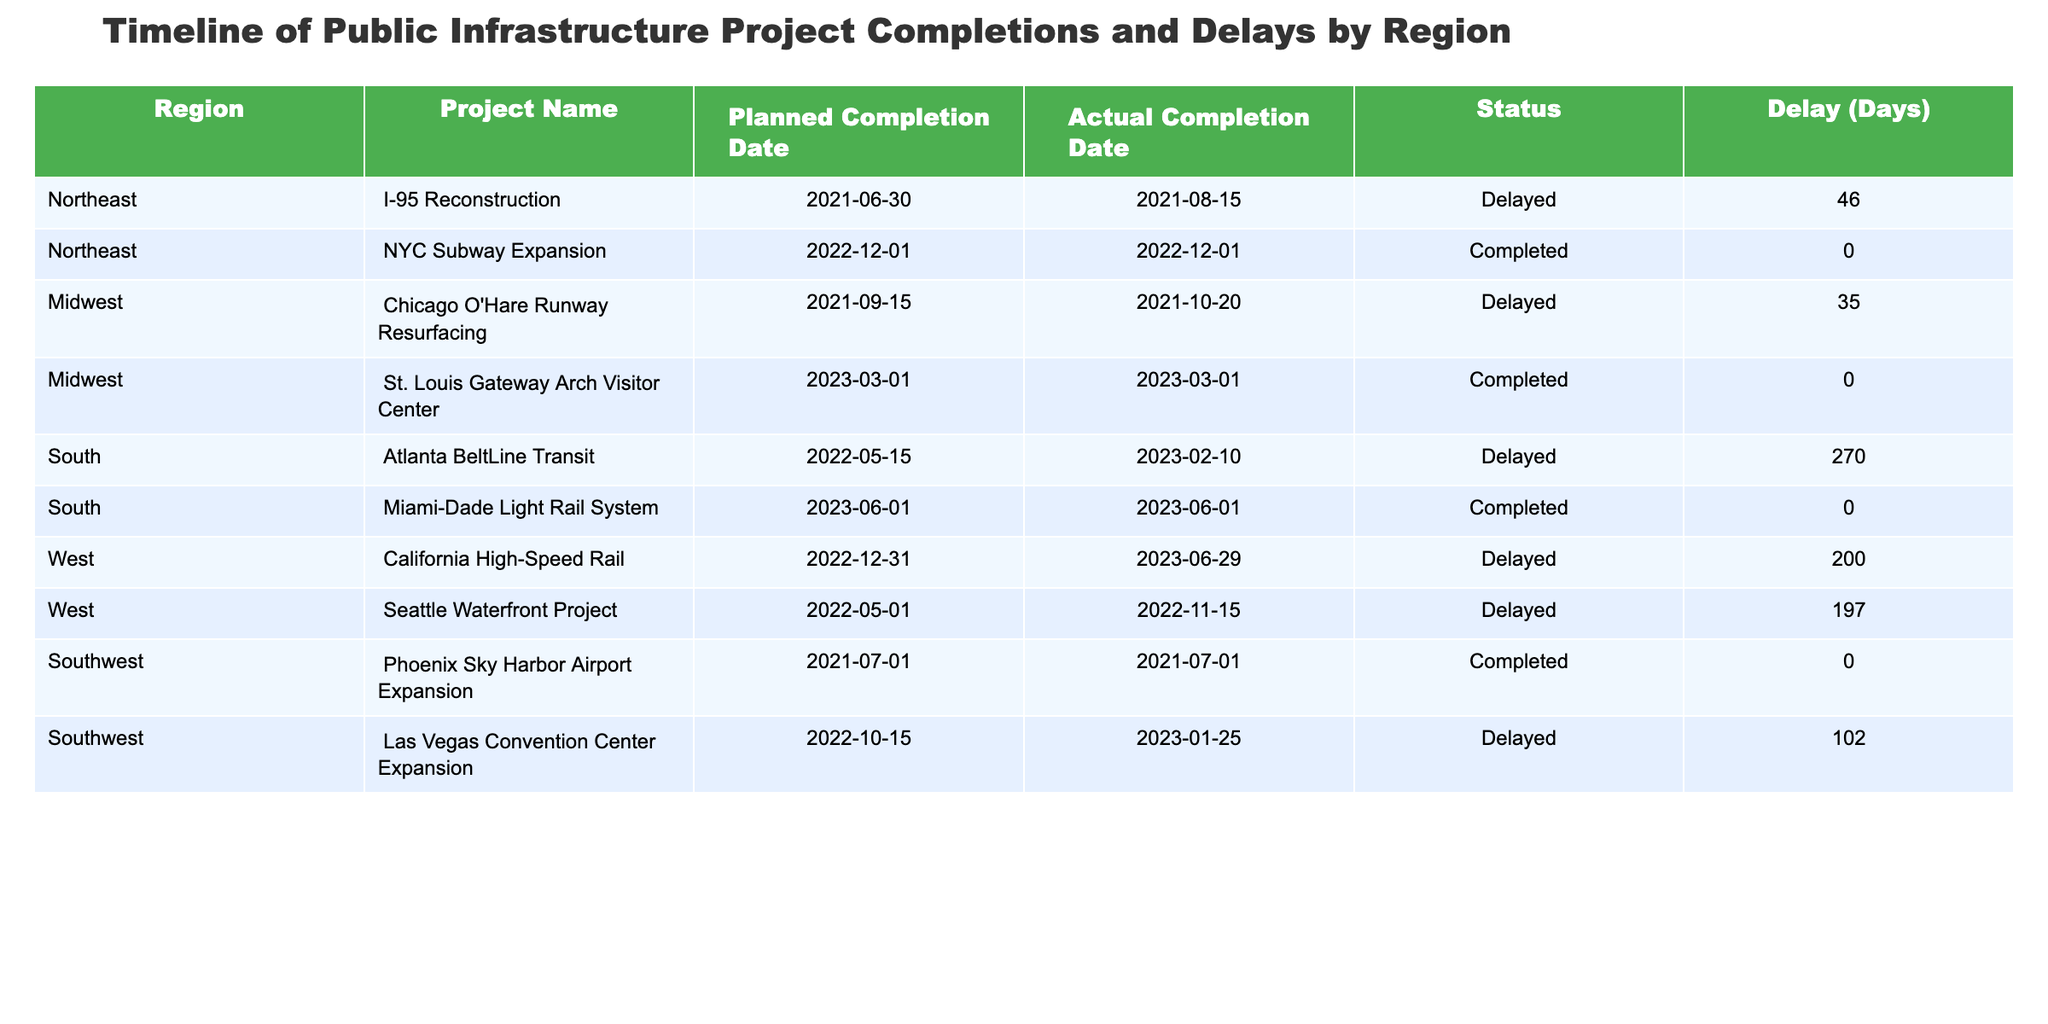What is the status of the "NYC Subway Expansion" project? The "NYC Subway Expansion" project shows an "Actual Completion Date" of 2022-12-01 and has a "Status" marked as "Completed."
Answer: Completed Which region has the highest total number of delays reported? By inspecting the table, I see that the South region has one project with a delay of 270 days, while the West reports delays for two projects totaling 397 days (200 + 197). Therefore, the West region has the highest total delays.
Answer: West How many projects were completed without delays across all regions? Looking at the table, I found three "Completed" projects without delays: NYC Subway Expansion, St. Louis Gateway Arch Visitor Center, and Miami-Dade Light Rail System. Thus, the total is three.
Answer: 3 What is the average delay for projects in the Northeast region? In the Northeast, there are two projects listed: I-95 Reconstruction (46 days delay) and NYC Subway Expansion (0 days delay). The average delay is calculated as (46 + 0) / 2 = 23 days.
Answer: 23 Is there any project in the Midwest that was completed on time? The table indicates that the "St. Louis Gateway Arch Visitor Center" had an "Actual Completion Date" matching its "Planned Completion Date," so it is completed on time.
Answer: Yes Which project faced the longest delay and how many days delayed was it? By reviewing all delays, the "Atlanta BeltLine Transit" experienced the longest delay of 270 days, making it the project with the most significant delay.
Answer: 270 List all the regions where projects were completed late. The table indicates projects in the Northeast, South, West, and Southwest regions were delayed. In total, there are four regions with delayed projects.
Answer: 4 How many total days of delays were reported across all projects? Summing up all the delays: 46 (Northeast) + 35 (Midwest) + 270 (South) + 200 (West) + 197 (West) + 102 (Southwest) gives a total of 850 days of delays across all projects.
Answer: 850 Did any region have all its projects completed on time? Examining the table, the Southwest region has one project completed on time (Phoenix Sky Harbor Airport Expansion), meaning it is not accurate to say it had all projects completed on time because it has another delayed project.
Answer: No What is the difference in delay days between the "California High-Speed Rail" project and the "Chicago O'Hare Runway Resurfacing"? The "California High-Speed Rail" project had a delay of 200 days while the "Chicago O'Hare Runway Resurfacing" had a delay of 35 days. The difference in delay days is 200 - 35 = 165 days.
Answer: 165 